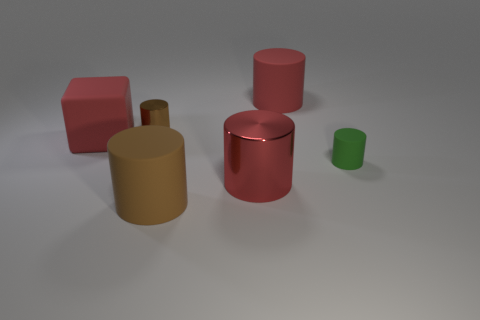Is the large red object behind the small brown cylinder made of the same material as the big block?
Your response must be concise. Yes. Are there more brown things on the right side of the large cube than big rubber cylinders behind the green rubber cylinder?
Provide a succinct answer. Yes. The brown matte cylinder is what size?
Your response must be concise. Large. There is a brown thing that is made of the same material as the big block; what shape is it?
Your answer should be very brief. Cylinder. Is the shape of the large rubber object behind the brown shiny thing the same as  the brown metallic thing?
Keep it short and to the point. Yes. How many objects are either rubber cubes or big red cylinders?
Ensure brevity in your answer.  3. What is the material of the big thing that is both in front of the red cube and behind the brown rubber cylinder?
Provide a short and direct response. Metal. Do the matte cube and the green rubber cylinder have the same size?
Your response must be concise. No. There is a object right of the big matte thing that is behind the small brown cylinder; how big is it?
Provide a succinct answer. Small. What number of small objects are behind the green object and in front of the red matte block?
Offer a terse response. 0. 